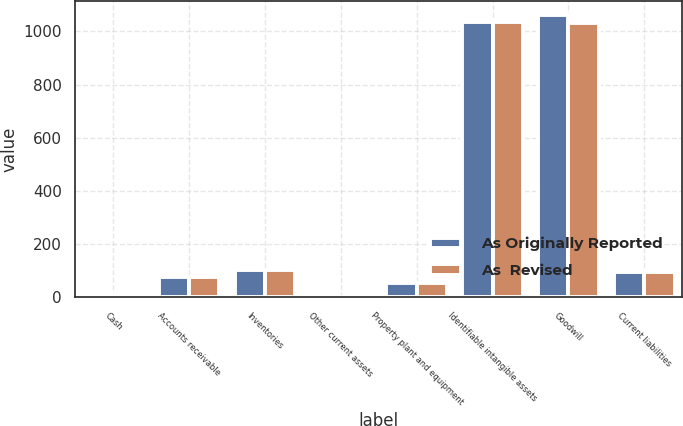<chart> <loc_0><loc_0><loc_500><loc_500><stacked_bar_chart><ecel><fcel>Cash<fcel>Accounts receivable<fcel>Inventories<fcel>Other current assets<fcel>Property plant and equipment<fcel>Identifiable intangible assets<fcel>Goodwill<fcel>Current liabilities<nl><fcel>As Originally Reported<fcel>11.8<fcel>75.9<fcel>102.4<fcel>2.9<fcel>53.4<fcel>1033.8<fcel>1061.9<fcel>97.2<nl><fcel>As  Revised<fcel>11.8<fcel>75.9<fcel>101.8<fcel>2.8<fcel>53.1<fcel>1033.8<fcel>1031<fcel>94.7<nl></chart> 